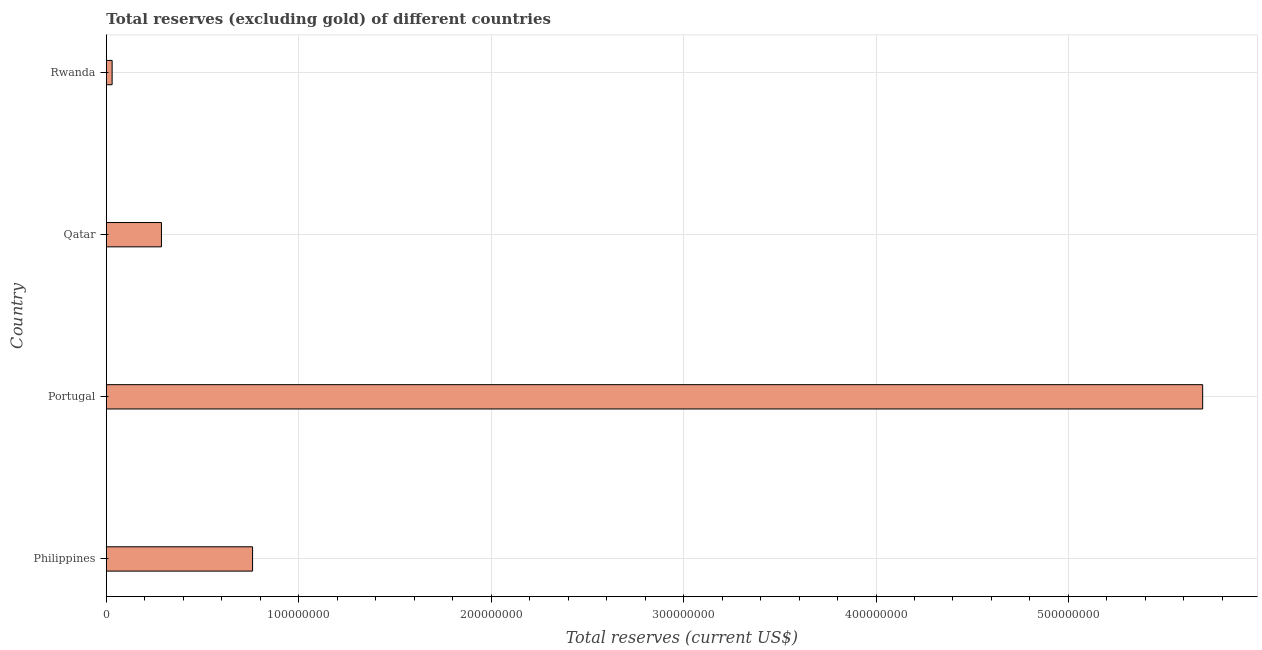Does the graph contain any zero values?
Keep it short and to the point. No. Does the graph contain grids?
Your answer should be compact. Yes. What is the title of the graph?
Give a very brief answer. Total reserves (excluding gold) of different countries. What is the label or title of the X-axis?
Offer a very short reply. Total reserves (current US$). What is the total reserves (excluding gold) in Rwanda?
Give a very brief answer. 3.01e+06. Across all countries, what is the maximum total reserves (excluding gold)?
Give a very brief answer. 5.70e+08. Across all countries, what is the minimum total reserves (excluding gold)?
Offer a very short reply. 3.01e+06. In which country was the total reserves (excluding gold) maximum?
Ensure brevity in your answer.  Portugal. In which country was the total reserves (excluding gold) minimum?
Give a very brief answer. Rwanda. What is the sum of the total reserves (excluding gold)?
Provide a succinct answer. 6.77e+08. What is the difference between the total reserves (excluding gold) in Philippines and Rwanda?
Your answer should be compact. 7.30e+07. What is the average total reserves (excluding gold) per country?
Provide a succinct answer. 1.69e+08. What is the median total reserves (excluding gold)?
Ensure brevity in your answer.  5.23e+07. What is the ratio of the total reserves (excluding gold) in Philippines to that in Qatar?
Offer a very short reply. 2.65. Is the difference between the total reserves (excluding gold) in Philippines and Portugal greater than the difference between any two countries?
Your answer should be compact. No. What is the difference between the highest and the second highest total reserves (excluding gold)?
Provide a short and direct response. 4.94e+08. What is the difference between the highest and the lowest total reserves (excluding gold)?
Give a very brief answer. 5.67e+08. How many bars are there?
Give a very brief answer. 4. How many countries are there in the graph?
Ensure brevity in your answer.  4. What is the difference between two consecutive major ticks on the X-axis?
Keep it short and to the point. 1.00e+08. What is the Total reserves (current US$) of Philippines?
Your response must be concise. 7.60e+07. What is the Total reserves (current US$) in Portugal?
Keep it short and to the point. 5.70e+08. What is the Total reserves (current US$) of Qatar?
Your response must be concise. 2.86e+07. What is the Total reserves (current US$) of Rwanda?
Provide a succinct answer. 3.01e+06. What is the difference between the Total reserves (current US$) in Philippines and Portugal?
Keep it short and to the point. -4.94e+08. What is the difference between the Total reserves (current US$) in Philippines and Qatar?
Keep it short and to the point. 4.74e+07. What is the difference between the Total reserves (current US$) in Philippines and Rwanda?
Provide a succinct answer. 7.30e+07. What is the difference between the Total reserves (current US$) in Portugal and Qatar?
Provide a succinct answer. 5.41e+08. What is the difference between the Total reserves (current US$) in Portugal and Rwanda?
Offer a terse response. 5.67e+08. What is the difference between the Total reserves (current US$) in Qatar and Rwanda?
Ensure brevity in your answer.  2.56e+07. What is the ratio of the Total reserves (current US$) in Philippines to that in Portugal?
Offer a terse response. 0.13. What is the ratio of the Total reserves (current US$) in Philippines to that in Qatar?
Your response must be concise. 2.65. What is the ratio of the Total reserves (current US$) in Philippines to that in Rwanda?
Your answer should be very brief. 25.25. What is the ratio of the Total reserves (current US$) in Portugal to that in Qatar?
Your response must be concise. 19.89. What is the ratio of the Total reserves (current US$) in Portugal to that in Rwanda?
Your answer should be very brief. 189.29. What is the ratio of the Total reserves (current US$) in Qatar to that in Rwanda?
Your answer should be compact. 9.52. 